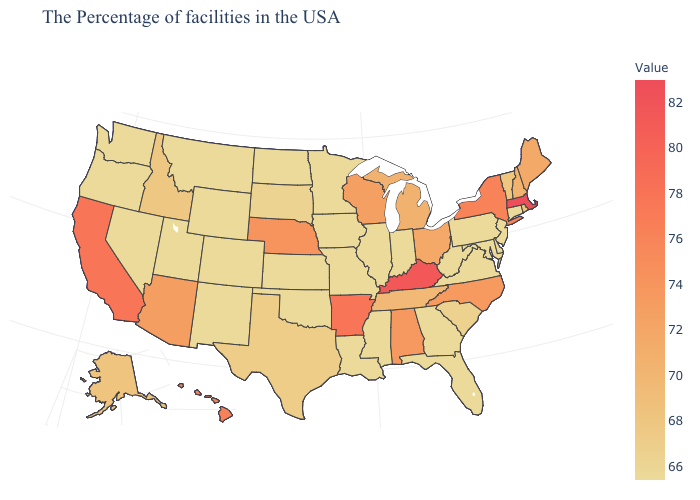Does Virginia have the lowest value in the USA?
Write a very short answer. Yes. Which states have the lowest value in the USA?
Answer briefly. Connecticut, New Jersey, Delaware, Maryland, Pennsylvania, Virginia, West Virginia, Florida, Georgia, Indiana, Illinois, Mississippi, Louisiana, Missouri, Minnesota, Iowa, Kansas, Oklahoma, North Dakota, Wyoming, Colorado, New Mexico, Utah, Montana, Nevada, Washington, Oregon. Is the legend a continuous bar?
Answer briefly. Yes. Does Connecticut have the lowest value in the Northeast?
Answer briefly. Yes. Does Nebraska have the highest value in the MidWest?
Concise answer only. Yes. 